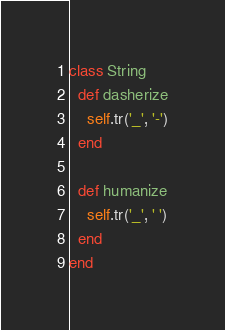Convert code to text. <code><loc_0><loc_0><loc_500><loc_500><_Ruby_>class String
  def dasherize
    self.tr('_', '-')
  end

  def humanize
    self.tr('_', ' ')
  end
end</code> 